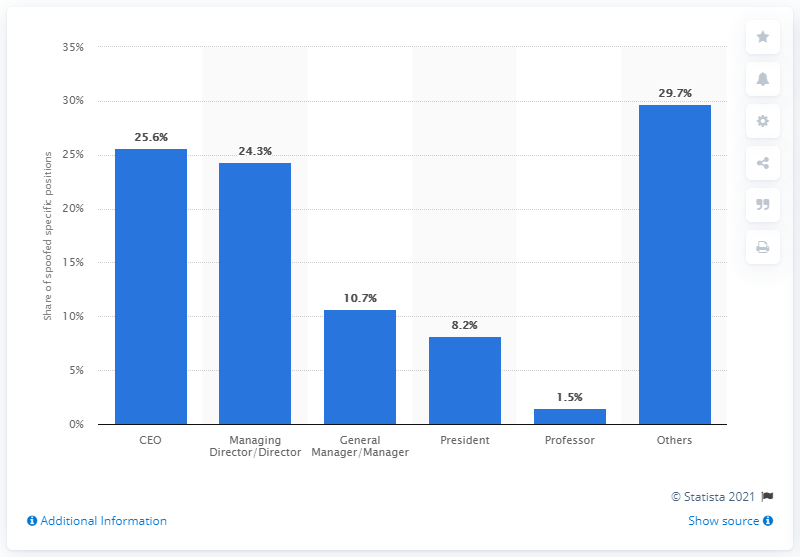Which roles besides CEO are commonly impersonated in BEC scams? Aside from the CEO, other roles commonly impersonated in BEC scams include Managing Directors/Directors at 24.3%, General Managers/Managers at 10.7%, and Presidents at 8.2%. The 'Others' category, which might include a variety of positions, has the highest percentage at 29.7%. Why might the 'Others' category be so high? The 'Others' category is likely high because it aggregates all the roles that are not explicitly listed, encompassing a wide range of positions within a company that scammers might impersonate. This could include finance personnel, legal advisors, or any trusted authority within the organization that has a lower representation individually but collectively represents a significant portion of impersonation cases. 